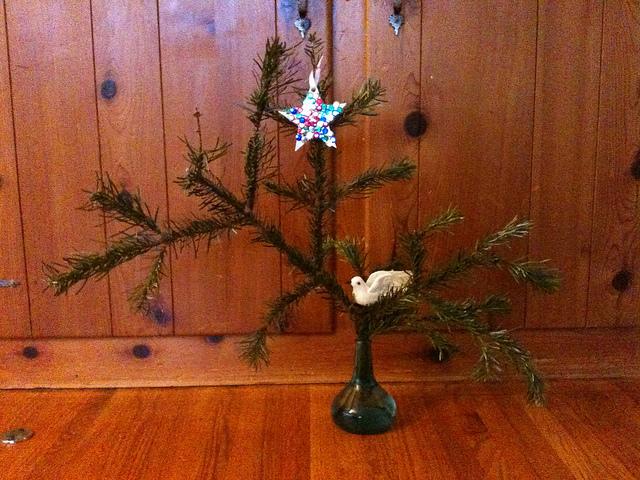What color is the floor?
Give a very brief answer. Brown. What time of year is it?
Write a very short answer. Christmas. What kind of material is used on the walls?
Write a very short answer. Wood. 